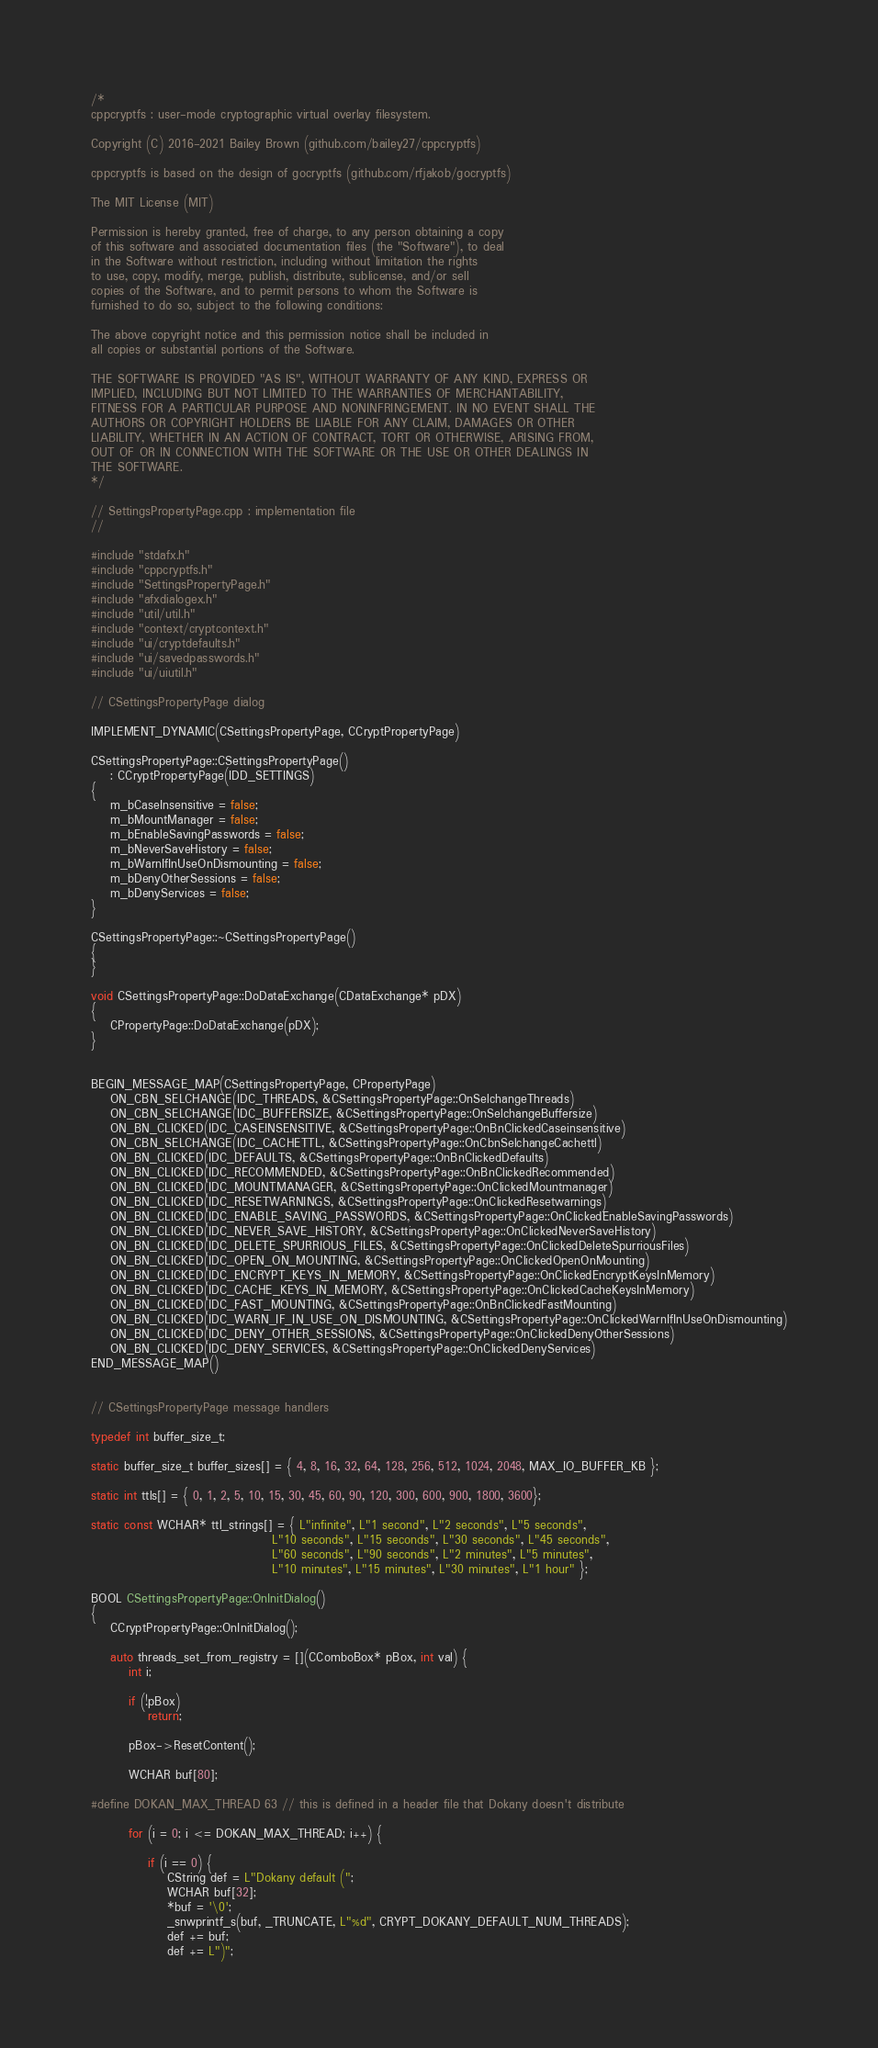<code> <loc_0><loc_0><loc_500><loc_500><_C++_>/*
cppcryptfs : user-mode cryptographic virtual overlay filesystem.

Copyright (C) 2016-2021 Bailey Brown (github.com/bailey27/cppcryptfs)

cppcryptfs is based on the design of gocryptfs (github.com/rfjakob/gocryptfs)

The MIT License (MIT)

Permission is hereby granted, free of charge, to any person obtaining a copy
of this software and associated documentation files (the "Software"), to deal
in the Software without restriction, including without limitation the rights
to use, copy, modify, merge, publish, distribute, sublicense, and/or sell
copies of the Software, and to permit persons to whom the Software is
furnished to do so, subject to the following conditions:

The above copyright notice and this permission notice shall be included in
all copies or substantial portions of the Software.

THE SOFTWARE IS PROVIDED "AS IS", WITHOUT WARRANTY OF ANY KIND, EXPRESS OR
IMPLIED, INCLUDING BUT NOT LIMITED TO THE WARRANTIES OF MERCHANTABILITY,
FITNESS FOR A PARTICULAR PURPOSE AND NONINFRINGEMENT. IN NO EVENT SHALL THE
AUTHORS OR COPYRIGHT HOLDERS BE LIABLE FOR ANY CLAIM, DAMAGES OR OTHER
LIABILITY, WHETHER IN AN ACTION OF CONTRACT, TORT OR OTHERWISE, ARISING FROM,
OUT OF OR IN CONNECTION WITH THE SOFTWARE OR THE USE OR OTHER DEALINGS IN
THE SOFTWARE.
*/

// SettingsPropertyPage.cpp : implementation file
//

#include "stdafx.h"
#include "cppcryptfs.h"
#include "SettingsPropertyPage.h"
#include "afxdialogex.h"
#include "util/util.h"
#include "context/cryptcontext.h"
#include "ui/cryptdefaults.h"
#include "ui/savedpasswords.h"
#include "ui/uiutil.h"

// CSettingsPropertyPage dialog

IMPLEMENT_DYNAMIC(CSettingsPropertyPage, CCryptPropertyPage)

CSettingsPropertyPage::CSettingsPropertyPage()
	: CCryptPropertyPage(IDD_SETTINGS)
{
	m_bCaseInsensitive = false;
	m_bMountManager = false;
	m_bEnableSavingPasswords = false;
	m_bNeverSaveHistory = false;
	m_bWarnIfInUseOnDismounting = false;
	m_bDenyOtherSessions = false;
	m_bDenyServices = false;
}

CSettingsPropertyPage::~CSettingsPropertyPage()
{
}

void CSettingsPropertyPage::DoDataExchange(CDataExchange* pDX)
{
	CPropertyPage::DoDataExchange(pDX);
}


BEGIN_MESSAGE_MAP(CSettingsPropertyPage, CPropertyPage)
	ON_CBN_SELCHANGE(IDC_THREADS, &CSettingsPropertyPage::OnSelchangeThreads)
	ON_CBN_SELCHANGE(IDC_BUFFERSIZE, &CSettingsPropertyPage::OnSelchangeBuffersize)
	ON_BN_CLICKED(IDC_CASEINSENSITIVE, &CSettingsPropertyPage::OnBnClickedCaseinsensitive)
	ON_CBN_SELCHANGE(IDC_CACHETTL, &CSettingsPropertyPage::OnCbnSelchangeCachettl)
	ON_BN_CLICKED(IDC_DEFAULTS, &CSettingsPropertyPage::OnBnClickedDefaults)
	ON_BN_CLICKED(IDC_RECOMMENDED, &CSettingsPropertyPage::OnBnClickedRecommended)
	ON_BN_CLICKED(IDC_MOUNTMANAGER, &CSettingsPropertyPage::OnClickedMountmanager)
	ON_BN_CLICKED(IDC_RESETWARNINGS, &CSettingsPropertyPage::OnClickedResetwarnings)
	ON_BN_CLICKED(IDC_ENABLE_SAVING_PASSWORDS, &CSettingsPropertyPage::OnClickedEnableSavingPasswords)
	ON_BN_CLICKED(IDC_NEVER_SAVE_HISTORY, &CSettingsPropertyPage::OnClickedNeverSaveHistory)
	ON_BN_CLICKED(IDC_DELETE_SPURRIOUS_FILES, &CSettingsPropertyPage::OnClickedDeleteSpurriousFiles)
	ON_BN_CLICKED(IDC_OPEN_ON_MOUNTING, &CSettingsPropertyPage::OnClickedOpenOnMounting)
	ON_BN_CLICKED(IDC_ENCRYPT_KEYS_IN_MEMORY, &CSettingsPropertyPage::OnClickedEncryptKeysInMemory)
	ON_BN_CLICKED(IDC_CACHE_KEYS_IN_MEMORY, &CSettingsPropertyPage::OnClickedCacheKeysInMemory)
	ON_BN_CLICKED(IDC_FAST_MOUNTING, &CSettingsPropertyPage::OnBnClickedFastMounting)
	ON_BN_CLICKED(IDC_WARN_IF_IN_USE_ON_DISMOUNTING, &CSettingsPropertyPage::OnClickedWarnIfInUseOnDismounting)
	ON_BN_CLICKED(IDC_DENY_OTHER_SESSIONS, &CSettingsPropertyPage::OnClickedDenyOtherSessions)
	ON_BN_CLICKED(IDC_DENY_SERVICES, &CSettingsPropertyPage::OnClickedDenyServices)
END_MESSAGE_MAP()


// CSettingsPropertyPage message handlers

typedef int buffer_size_t;

static buffer_size_t buffer_sizes[] = { 4, 8, 16, 32, 64, 128, 256, 512, 1024, 2048, MAX_IO_BUFFER_KB };

static int ttls[] = { 0, 1, 2, 5, 10, 15, 30, 45, 60, 90, 120, 300, 600, 900, 1800, 3600};

static const WCHAR* ttl_strings[] = { L"infinite", L"1 second", L"2 seconds", L"5 seconds", 
									  L"10 seconds", L"15 seconds", L"30 seconds", L"45 seconds", 
									  L"60 seconds", L"90 seconds", L"2 minutes", L"5 minutes", 
									  L"10 minutes", L"15 minutes", L"30 minutes", L"1 hour" };

BOOL CSettingsPropertyPage::OnInitDialog()
{
	CCryptPropertyPage::OnInitDialog();

	auto threads_set_from_registry = [](CComboBox* pBox, int val) {
		int i;		

		if (!pBox)
			return;

		pBox->ResetContent();

		WCHAR buf[80];

#define DOKAN_MAX_THREAD 63 // this is defined in a header file that Dokany doesn't distribute

		for (i = 0; i <= DOKAN_MAX_THREAD; i++) {

			if (i == 0) {
				CString def = L"Dokany default (";
				WCHAR buf[32];
				*buf = '\0';
				_snwprintf_s(buf, _TRUNCATE, L"%d", CRYPT_DOKANY_DEFAULT_NUM_THREADS);
				def += buf;
				def += L")";</code> 